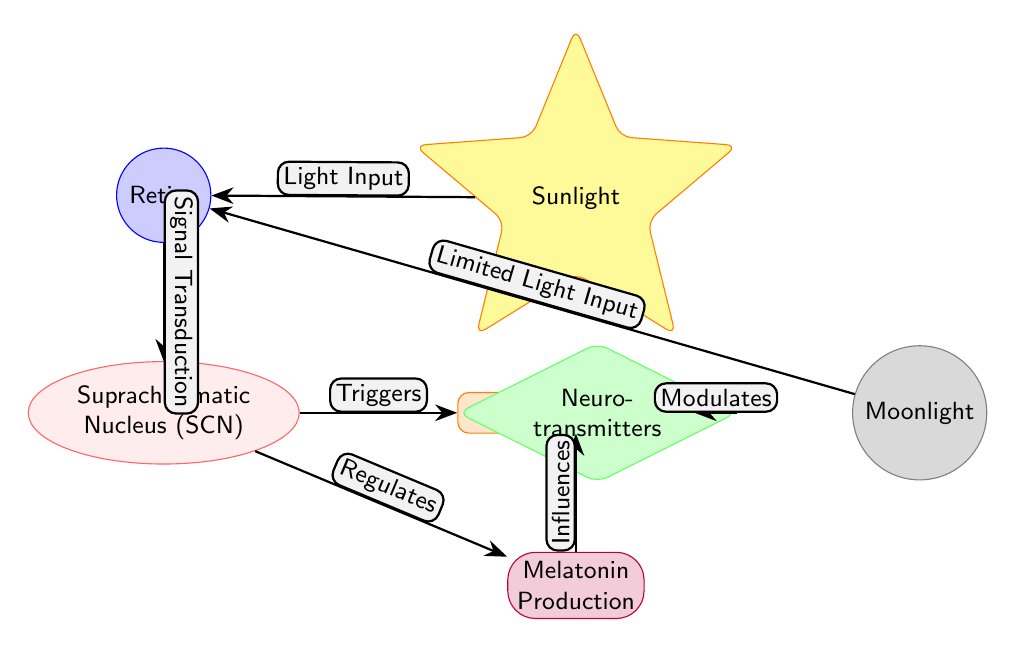What is the main central node of the diagram? The main central node represents "Circadian Rhythms" and is positioned at the center of the diagram, indicating its central role in the relationships depicted.
Answer: Circadian Rhythms What influences melatonin production according to the diagram? The arrow from the "Suprachiasmatic Nucleus (SCN)" to "Melatonin Production" indicates that the SCN regulates melatonin production, meaning it has a direct influence on this process.
Answer: Suprachiasmatic Nucleus (SCN) How many different sources of light are represented in the diagram? The diagram depicts two sources of light: "Sunlight" and "Moonlight," each connected to the visual systems influencing circadian rhythms.
Answer: 2 What is the effect of limited light input according to the diagram? The edge labeled "Limited Light Input" connects "Moonlight" to "Retina," indicating that limited input from moonlight affects the information processed by the retina, but does not directly link to other outputs like circadian rhythms.
Answer: Retina Which node is associated with neurotransmitters? The "Neurotransmitters" node is identified as a diamond shape located to the right of the "Suprachiasmatic Nucleus (SCN)" and is described as modulating the output related to circadian rhythms, indicating its critical function in this context.
Answer: Neurotransmitters What is the relationship between retina and suprachiasmatic nucleus? The diagram shows a directional edge labeled "Signal Transduction" that flows from "Retina" to "Suprachiasmatic Nucleus (SCN)," representing how light information from the retina is transmitted to the SCN.
Answer: Signal Transduction Which hormone is produced in response to circadian rhythms? The edge leading from the central node "Circadian Rhythms" to "Melatonin Production" indicates that melatonin is the hormone produced as a response to circadian rhythms, integrating biological cycles with hormonal responses.
Answer: Melatonin What modulates circadian rhythms via neurotransmitters? The diagram illustrates that "Neurotransmitters" have a role in modulating circadian rhythms, as shown by the edge labeled "Modulates" that connects it to the central node of "Circadian Rhythms."
Answer: Neurotransmitters What role does sunlight play in the diagram? The "Sunlight" node directs light input to the "Retina," subsequently transmitting a signal to the "Suprachiasmatic Nucleus (SCN)" which indicates that sunlight is essential for setting the biological clock through visual signals.
Answer: Light Input 